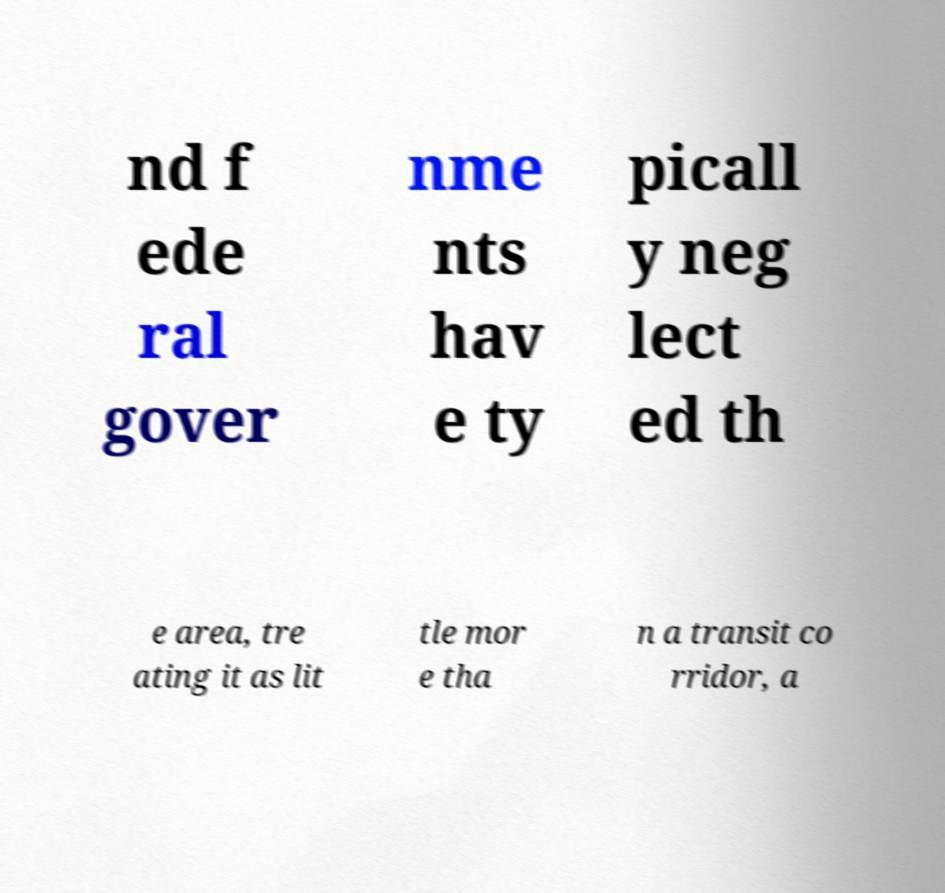Can you read and provide the text displayed in the image?This photo seems to have some interesting text. Can you extract and type it out for me? nd f ede ral gover nme nts hav e ty picall y neg lect ed th e area, tre ating it as lit tle mor e tha n a transit co rridor, a 